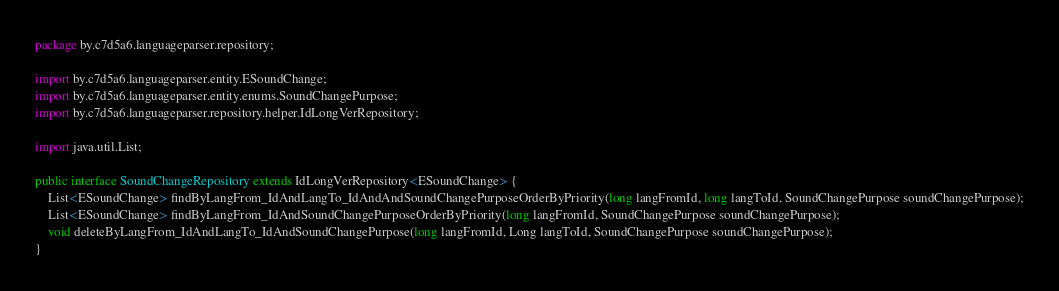Convert code to text. <code><loc_0><loc_0><loc_500><loc_500><_Java_>package by.c7d5a6.languageparser.repository;

import by.c7d5a6.languageparser.entity.ESoundChange;
import by.c7d5a6.languageparser.entity.enums.SoundChangePurpose;
import by.c7d5a6.languageparser.repository.helper.IdLongVerRepository;

import java.util.List;

public interface SoundChangeRepository extends IdLongVerRepository<ESoundChange> {
    List<ESoundChange> findByLangFrom_IdAndLangTo_IdAndAndSoundChangePurposeOrderByPriority(long langFromId, long langToId, SoundChangePurpose soundChangePurpose);
    List<ESoundChange> findByLangFrom_IdAndSoundChangePurposeOrderByPriority(long langFromId, SoundChangePurpose soundChangePurpose);
    void deleteByLangFrom_IdAndLangTo_IdAndSoundChangePurpose(long langFromId, Long langToId, SoundChangePurpose soundChangePurpose);
}
</code> 